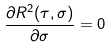Convert formula to latex. <formula><loc_0><loc_0><loc_500><loc_500>\frac { \partial R ^ { 2 } ( \tau , \sigma ) } { \partial \sigma } = 0</formula> 